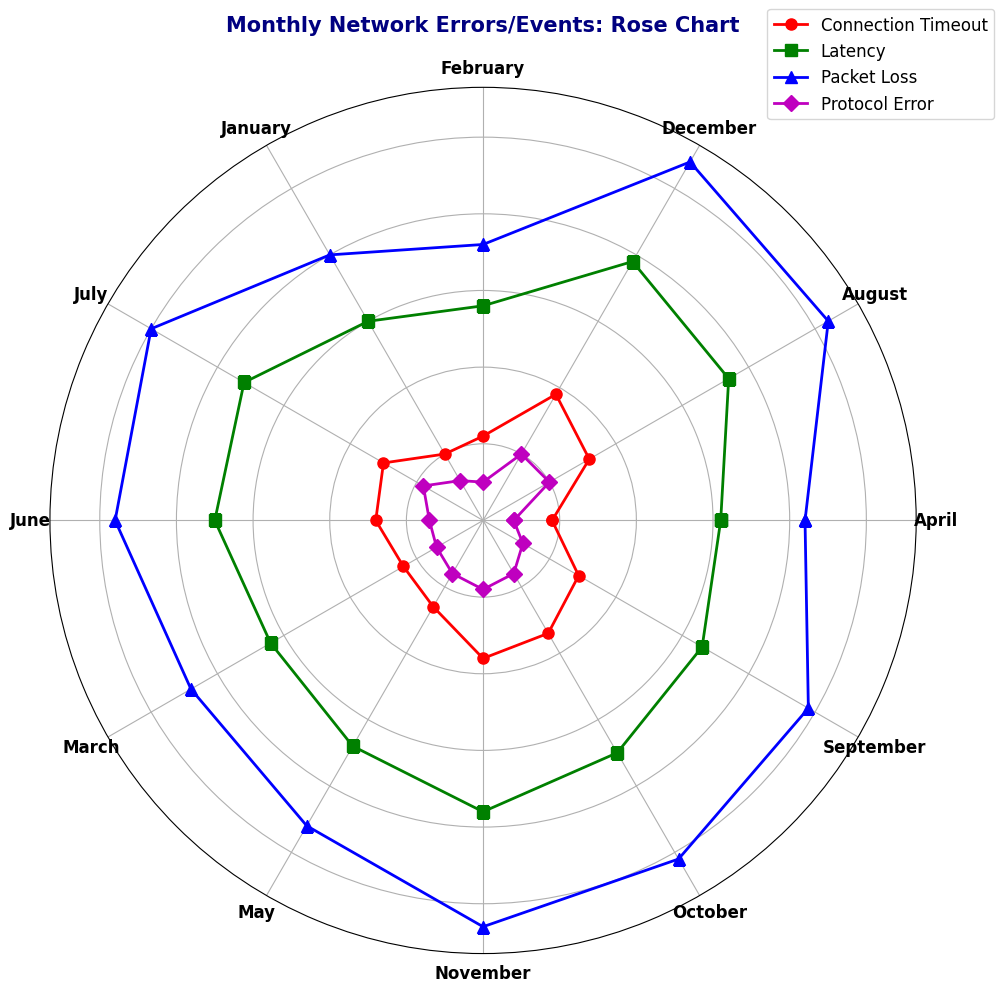Which type of network event has the highest frequency in December? The rose chart shows different network events for each month. By checking December, we see the longest bar, which represents the highest frequency. For December, Packet Loss has the highest frequency at 270.
Answer: Packet Loss How does the frequency of Latency in May compare to that in June? In May, the rose chart shows the value for Latency as 170 and for June it is 175. Comparing these, the frequency of Latency is higher in June.
Answer: Higher in June What is the total frequency of Protocol Errors from January to March? The rose chart shows Protocol Errors for January (30), February (25), and March (35). Summing these values: 30 + 25 + 35 = 90.
Answer: 90 Which month has the lowest frequency of Connection Timeout and what is it? By looking at the shortest bar for Connection Timeout, the lowest value appears in January at 50.
Answer: January, 50 Is the frequency of Packet Loss higher in July or August? Checking the lengths of the bars for Packet Loss in July (250) and August (260), August has a higher frequency.
Answer: August What is the average frequency of Latency over the entire year? The rose chart displays Latency values for each month. Summing these values: 150 + 140 + 160 + 155 + 170 + 175 + 180 + 185 + 165 + 175 + 190 + 195 = 2140. There are 12 months, so 2140 / 12 = 178.33.
Answer: 178.33 By how much did the frequency of Packet Loss increase from February to March? The rose chart indicates Packet Loss values of 180 in February and 220 in March. The difference is 220 - 180 = 40.
Answer: 40 Is the frequency of Protocol Errors constant during the last three months of the year? Observing Protocol Errors for October (40), November (45), and December (50), they are not constant and gradually increase.
Answer: No Which month shows the highest frequency of Connection Timeout, and what is the value? The rose chart shows the highest bar for Connection Timeout in December with a frequency of 95.
Answer: December, 95 